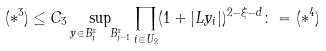<formula> <loc_0><loc_0><loc_500><loc_500>( * ^ { 3 } ) \leq C _ { 3 } \sup _ { y \in B ^ { x } _ { j } \ B ^ { x } _ { j - 1 } } \prod _ { i \in U _ { 2 } } ( 1 + | L y _ { i } | ) ^ { 2 - \xi - d } \colon = ( * ^ { 4 } )</formula> 